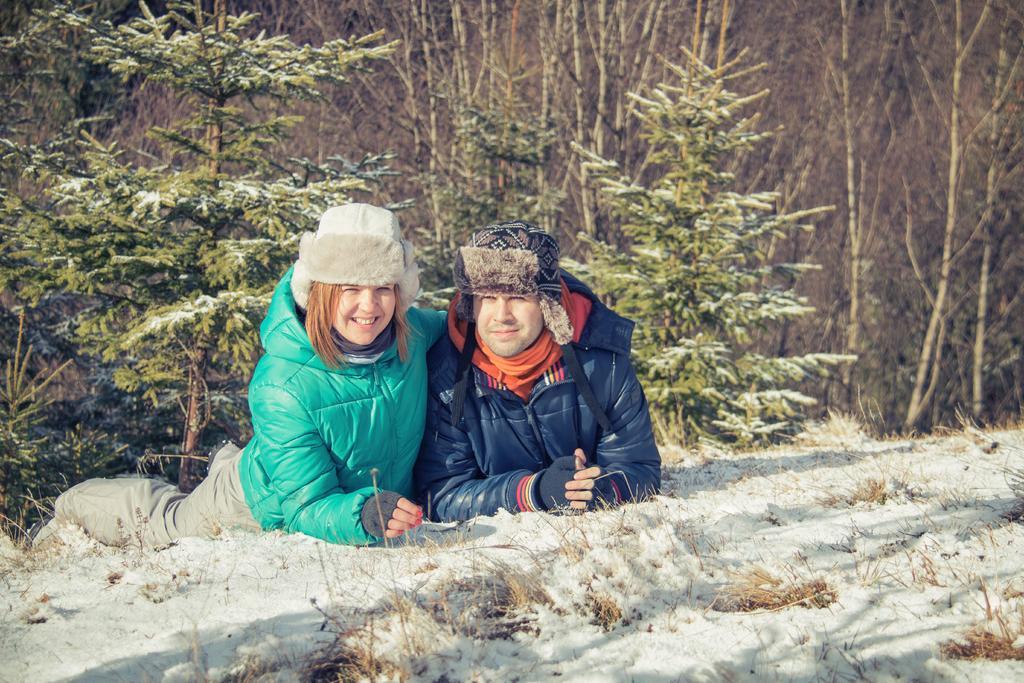How would you summarize this image in a sentence or two? There is a woman in green color coat, smiling and keeping hand on the person who is in violet color coat and is smiling. These both persons are laying on the ground on which, there is snow. In the background, there are plants on which, there is snow and there are trees. 